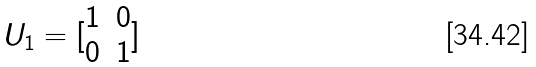<formula> <loc_0><loc_0><loc_500><loc_500>U _ { 1 } = [ \begin{matrix} 1 & 0 \\ 0 & 1 \end{matrix} ]</formula> 